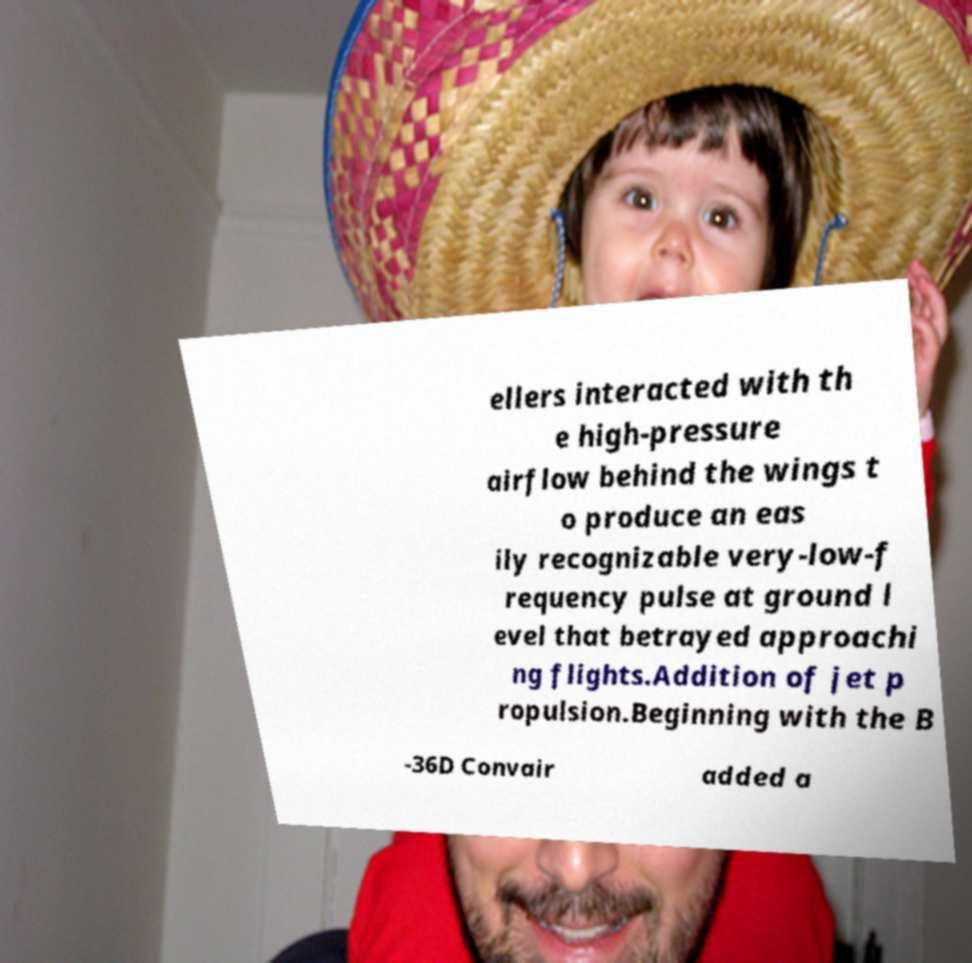Please identify and transcribe the text found in this image. ellers interacted with th e high-pressure airflow behind the wings t o produce an eas ily recognizable very-low-f requency pulse at ground l evel that betrayed approachi ng flights.Addition of jet p ropulsion.Beginning with the B -36D Convair added a 